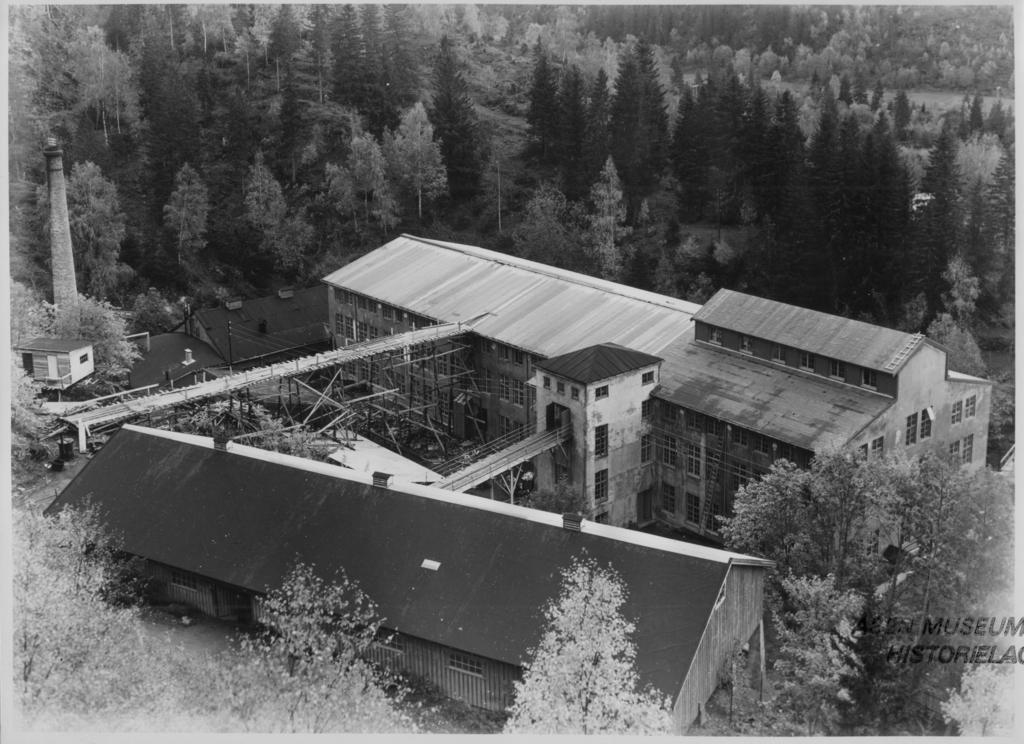Please provide a concise description of this image. This is a black and white image, in this image there are trees and a factory, in the bottom right there is text. 